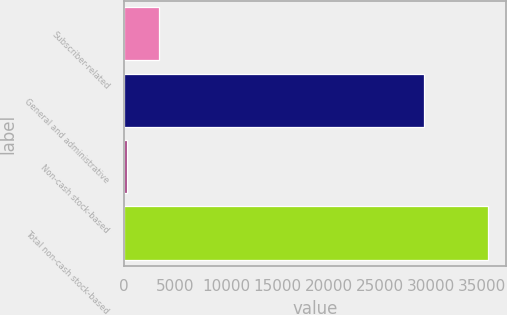Convert chart to OTSL. <chart><loc_0><loc_0><loc_500><loc_500><bar_chart><fcel>Subscriber-related<fcel>General and administrative<fcel>Non-cash stock-based<fcel>Total non-cash stock-based<nl><fcel>3429.3<fcel>29299<fcel>308<fcel>35541.6<nl></chart> 